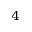<formula> <loc_0><loc_0><loc_500><loc_500>^ { 4 }</formula> 